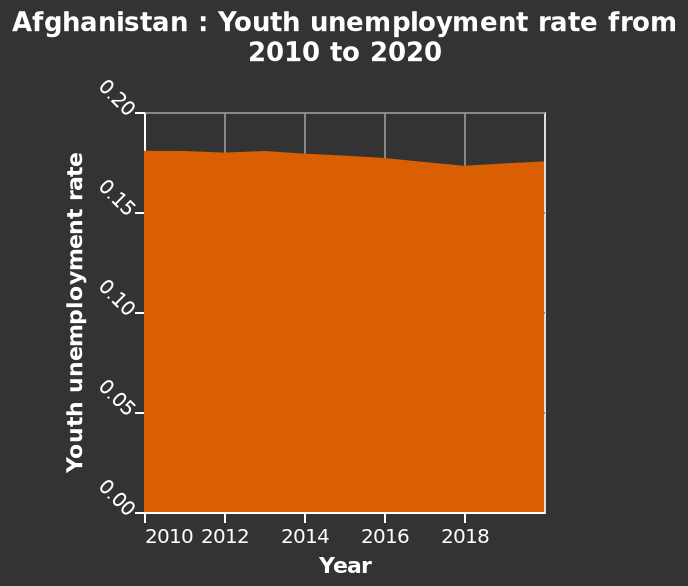<image>
Has youth unemployment been decreasing or increasing recently? Youth unemployment has experienced a slight rise after a slight decline in 2018. Has there been any significant change in youth unemployment recently? No significant change has been observed in youth unemployment recently, except for a slight increase after 2018. 